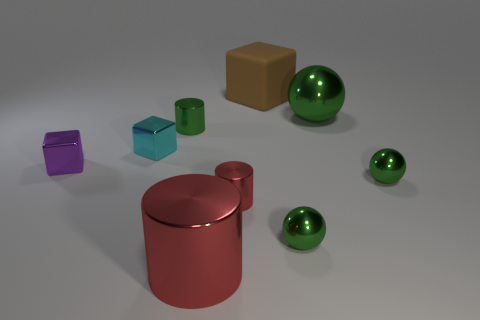Subtract all small shiny blocks. How many blocks are left? 1 Subtract all brown cubes. How many red cylinders are left? 2 Add 1 cylinders. How many objects exist? 10 Subtract 1 cylinders. How many cylinders are left? 2 Subtract all purple cylinders. Subtract all brown balls. How many cylinders are left? 3 Add 9 big yellow metallic blocks. How many big yellow metallic blocks exist? 9 Subtract 0 gray blocks. How many objects are left? 9 Subtract all blocks. How many objects are left? 6 Subtract all tiny purple balls. Subtract all green metallic cylinders. How many objects are left? 8 Add 7 big rubber objects. How many big rubber objects are left? 8 